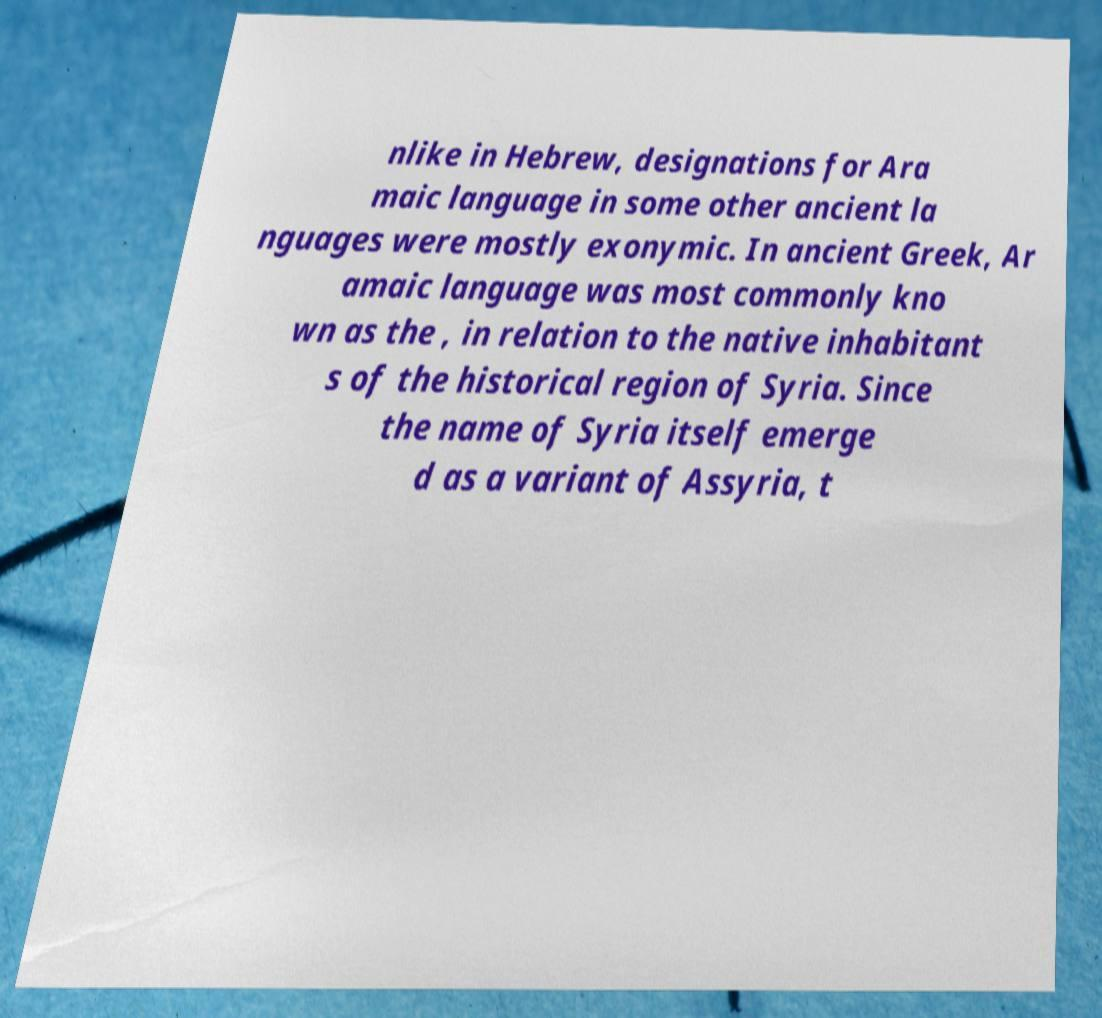I need the written content from this picture converted into text. Can you do that? nlike in Hebrew, designations for Ara maic language in some other ancient la nguages were mostly exonymic. In ancient Greek, Ar amaic language was most commonly kno wn as the , in relation to the native inhabitant s of the historical region of Syria. Since the name of Syria itself emerge d as a variant of Assyria, t 